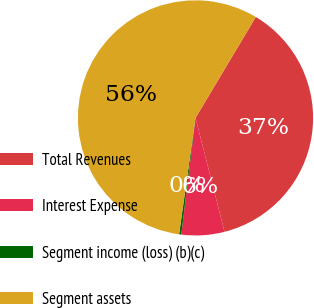Convert chart. <chart><loc_0><loc_0><loc_500><loc_500><pie_chart><fcel>Total Revenues<fcel>Interest Expense<fcel>Segment income (loss) (b)(c)<fcel>Segment assets<nl><fcel>37.46%<fcel>5.9%<fcel>0.3%<fcel>56.34%<nl></chart> 